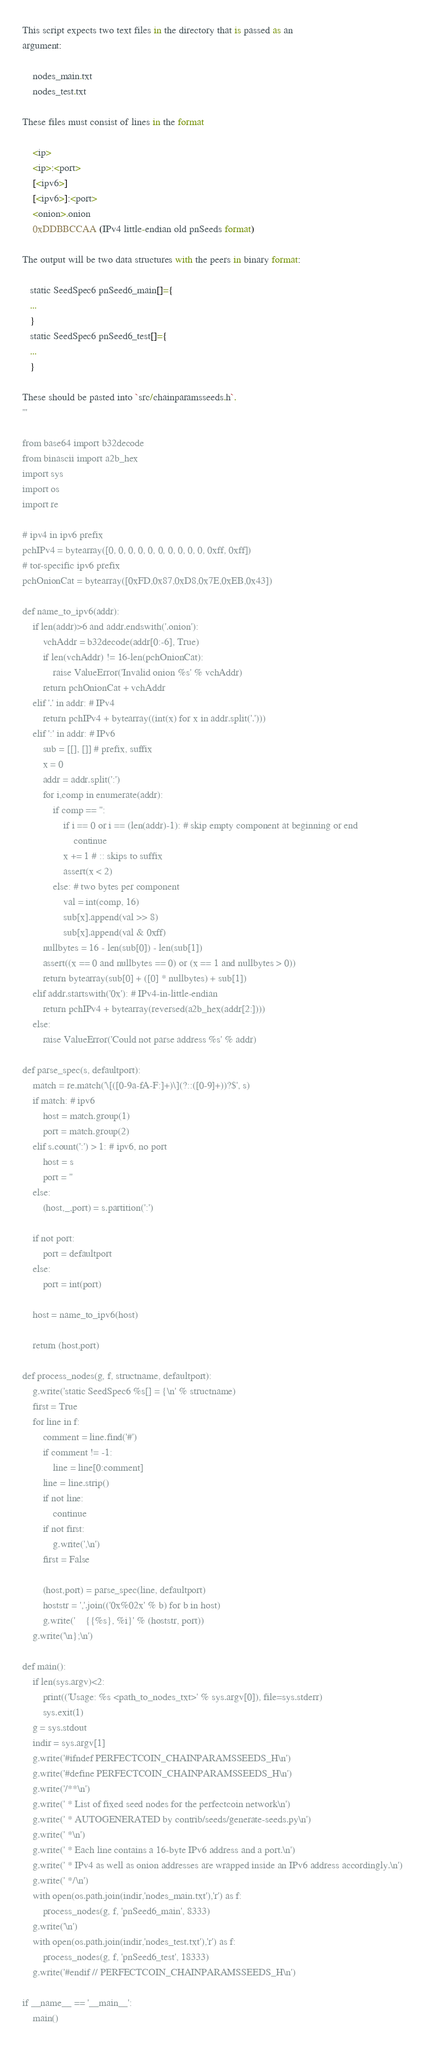<code> <loc_0><loc_0><loc_500><loc_500><_Python_>
This script expects two text files in the directory that is passed as an
argument:

    nodes_main.txt
    nodes_test.txt

These files must consist of lines in the format

    <ip>
    <ip>:<port>
    [<ipv6>]
    [<ipv6>]:<port>
    <onion>.onion
    0xDDBBCCAA (IPv4 little-endian old pnSeeds format)

The output will be two data structures with the peers in binary format:

   static SeedSpec6 pnSeed6_main[]={
   ...
   }
   static SeedSpec6 pnSeed6_test[]={
   ...
   }

These should be pasted into `src/chainparamsseeds.h`.
'''

from base64 import b32decode
from binascii import a2b_hex
import sys
import os
import re

# ipv4 in ipv6 prefix
pchIPv4 = bytearray([0, 0, 0, 0, 0, 0, 0, 0, 0, 0, 0xff, 0xff])
# tor-specific ipv6 prefix
pchOnionCat = bytearray([0xFD,0x87,0xD8,0x7E,0xEB,0x43])

def name_to_ipv6(addr):
    if len(addr)>6 and addr.endswith('.onion'):
        vchAddr = b32decode(addr[0:-6], True)
        if len(vchAddr) != 16-len(pchOnionCat):
            raise ValueError('Invalid onion %s' % vchAddr)
        return pchOnionCat + vchAddr
    elif '.' in addr: # IPv4
        return pchIPv4 + bytearray((int(x) for x in addr.split('.')))
    elif ':' in addr: # IPv6
        sub = [[], []] # prefix, suffix
        x = 0
        addr = addr.split(':')
        for i,comp in enumerate(addr):
            if comp == '':
                if i == 0 or i == (len(addr)-1): # skip empty component at beginning or end
                    continue
                x += 1 # :: skips to suffix
                assert(x < 2)
            else: # two bytes per component
                val = int(comp, 16)
                sub[x].append(val >> 8)
                sub[x].append(val & 0xff)
        nullbytes = 16 - len(sub[0]) - len(sub[1])
        assert((x == 0 and nullbytes == 0) or (x == 1 and nullbytes > 0))
        return bytearray(sub[0] + ([0] * nullbytes) + sub[1])
    elif addr.startswith('0x'): # IPv4-in-little-endian
        return pchIPv4 + bytearray(reversed(a2b_hex(addr[2:])))
    else:
        raise ValueError('Could not parse address %s' % addr)

def parse_spec(s, defaultport):
    match = re.match('\[([0-9a-fA-F:]+)\](?::([0-9]+))?$', s)
    if match: # ipv6
        host = match.group(1)
        port = match.group(2)
    elif s.count(':') > 1: # ipv6, no port
        host = s
        port = ''
    else:
        (host,_,port) = s.partition(':')

    if not port:
        port = defaultport
    else:
        port = int(port)

    host = name_to_ipv6(host)

    return (host,port)

def process_nodes(g, f, structname, defaultport):
    g.write('static SeedSpec6 %s[] = {\n' % structname)
    first = True
    for line in f:
        comment = line.find('#')
        if comment != -1:
            line = line[0:comment]
        line = line.strip()
        if not line:
            continue
        if not first:
            g.write(',\n')
        first = False

        (host,port) = parse_spec(line, defaultport)
        hoststr = ','.join(('0x%02x' % b) for b in host)
        g.write('    {{%s}, %i}' % (hoststr, port))
    g.write('\n};\n')

def main():
    if len(sys.argv)<2:
        print(('Usage: %s <path_to_nodes_txt>' % sys.argv[0]), file=sys.stderr)
        sys.exit(1)
    g = sys.stdout
    indir = sys.argv[1]
    g.write('#ifndef PERFECTCOIN_CHAINPARAMSSEEDS_H\n')
    g.write('#define PERFECTCOIN_CHAINPARAMSSEEDS_H\n')
    g.write('/**\n')
    g.write(' * List of fixed seed nodes for the perfectcoin network\n')
    g.write(' * AUTOGENERATED by contrib/seeds/generate-seeds.py\n')
    g.write(' *\n')
    g.write(' * Each line contains a 16-byte IPv6 address and a port.\n')
    g.write(' * IPv4 as well as onion addresses are wrapped inside an IPv6 address accordingly.\n')
    g.write(' */\n')
    with open(os.path.join(indir,'nodes_main.txt'),'r') as f:
        process_nodes(g, f, 'pnSeed6_main', 8333)
    g.write('\n')
    with open(os.path.join(indir,'nodes_test.txt'),'r') as f:
        process_nodes(g, f, 'pnSeed6_test', 18333)
    g.write('#endif // PERFECTCOIN_CHAINPARAMSSEEDS_H\n')

if __name__ == '__main__':
    main()

</code> 